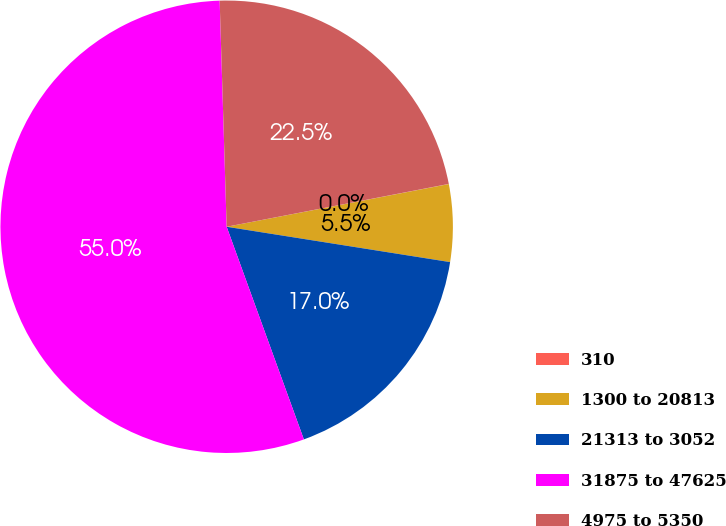Convert chart to OTSL. <chart><loc_0><loc_0><loc_500><loc_500><pie_chart><fcel>310<fcel>1300 to 20813<fcel>21313 to 3052<fcel>31875 to 47625<fcel>4975 to 5350<nl><fcel>0.01%<fcel>5.52%<fcel>16.96%<fcel>55.05%<fcel>22.46%<nl></chart> 